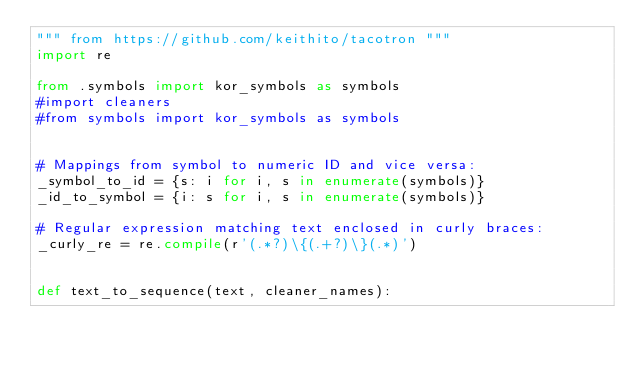<code> <loc_0><loc_0><loc_500><loc_500><_Python_>""" from https://github.com/keithito/tacotron """
import re

from .symbols import kor_symbols as symbols
#import cleaners
#from symbols import kor_symbols as symbols


# Mappings from symbol to numeric ID and vice versa:
_symbol_to_id = {s: i for i, s in enumerate(symbols)}
_id_to_symbol = {i: s for i, s in enumerate(symbols)}

# Regular expression matching text enclosed in curly braces:
_curly_re = re.compile(r'(.*?)\{(.+?)\}(.*)')


def text_to_sequence(text, cleaner_names):</code> 